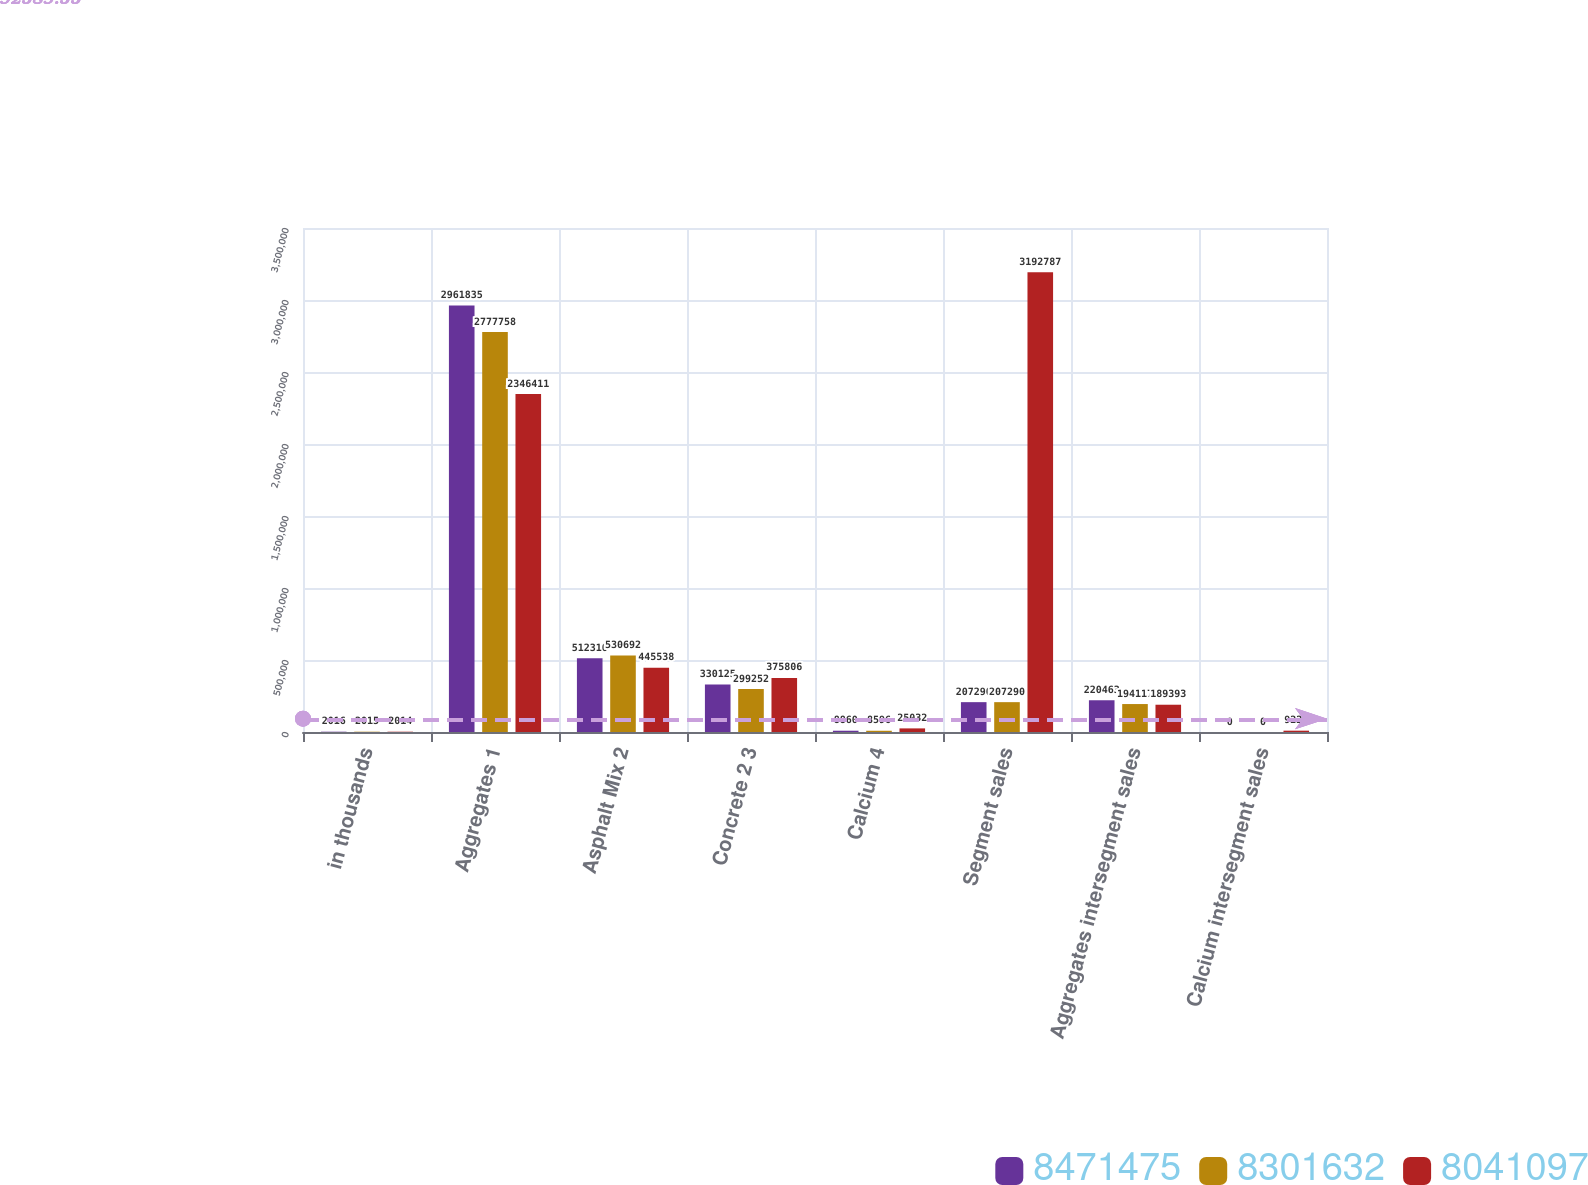<chart> <loc_0><loc_0><loc_500><loc_500><stacked_bar_chart><ecel><fcel>in thousands<fcel>Aggregates 1<fcel>Asphalt Mix 2<fcel>Concrete 2 3<fcel>Calcium 4<fcel>Segment sales<fcel>Aggregates intersegment sales<fcel>Calcium intersegment sales<nl><fcel>8.47148e+06<fcel>2016<fcel>2.96184e+06<fcel>512310<fcel>330125<fcel>8860<fcel>207290<fcel>220463<fcel>0<nl><fcel>8.30163e+06<fcel>2015<fcel>2.77776e+06<fcel>530692<fcel>299252<fcel>8596<fcel>207290<fcel>194117<fcel>0<nl><fcel>8.0411e+06<fcel>2014<fcel>2.34641e+06<fcel>445538<fcel>375806<fcel>25032<fcel>3.19279e+06<fcel>189393<fcel>9225<nl></chart> 